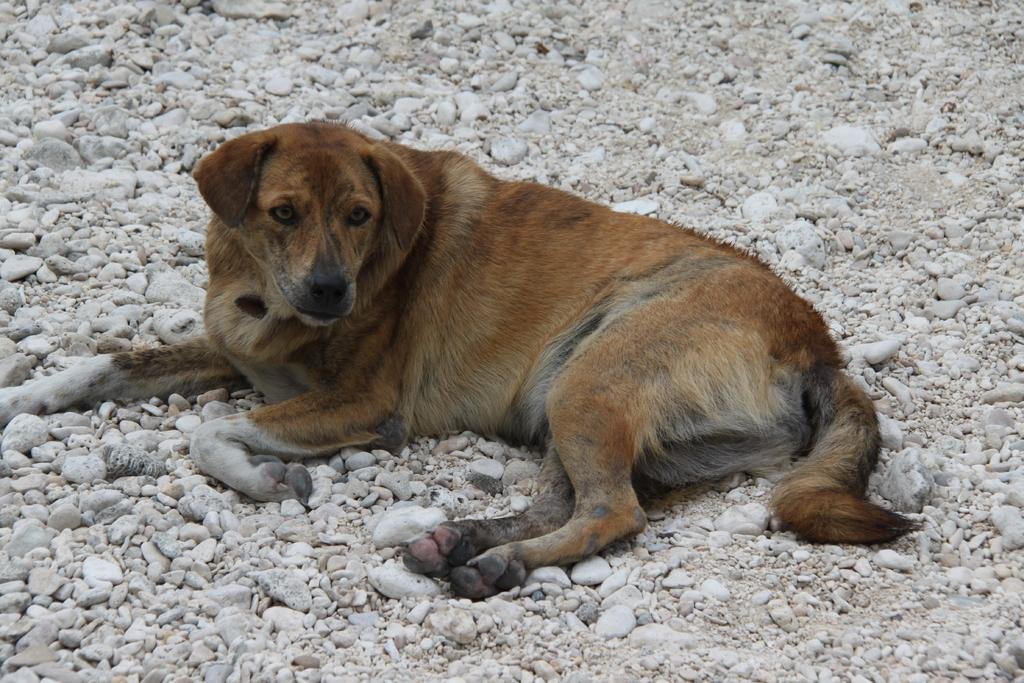What animal can be seen in the image? There is a dog in the image. What is the dog lying on? The dog is lying on stones. What type of pot is hanging from the hook in the image? There is no pot or hook present in the image; it features a dog lying on stones. 